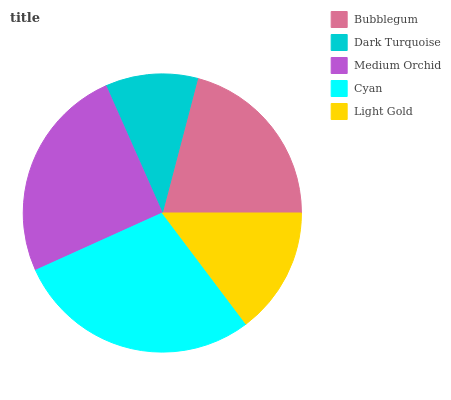Is Dark Turquoise the minimum?
Answer yes or no. Yes. Is Cyan the maximum?
Answer yes or no. Yes. Is Medium Orchid the minimum?
Answer yes or no. No. Is Medium Orchid the maximum?
Answer yes or no. No. Is Medium Orchid greater than Dark Turquoise?
Answer yes or no. Yes. Is Dark Turquoise less than Medium Orchid?
Answer yes or no. Yes. Is Dark Turquoise greater than Medium Orchid?
Answer yes or no. No. Is Medium Orchid less than Dark Turquoise?
Answer yes or no. No. Is Bubblegum the high median?
Answer yes or no. Yes. Is Bubblegum the low median?
Answer yes or no. Yes. Is Medium Orchid the high median?
Answer yes or no. No. Is Dark Turquoise the low median?
Answer yes or no. No. 